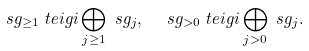Convert formula to latex. <formula><loc_0><loc_0><loc_500><loc_500>& \ s g _ { \geq 1 } \ t e i g i \bigoplus _ { j \geq 1 } \ s g _ { j } , \quad \ s g _ { > 0 } \ t e i g i \bigoplus _ { j > 0 } \ s g _ { j } .</formula> 